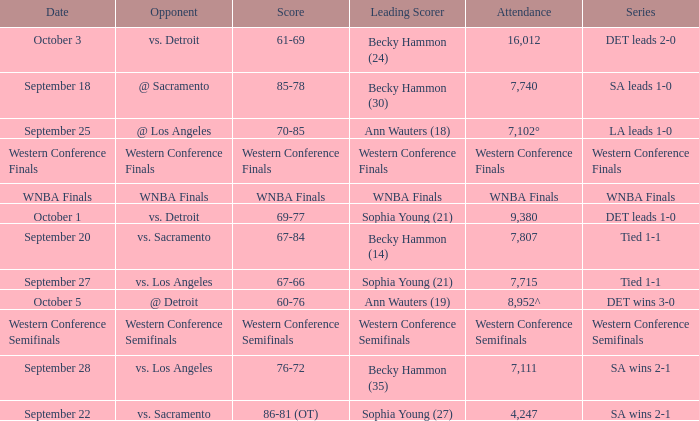What is the attendance of the western conference finals series? Western Conference Finals. 